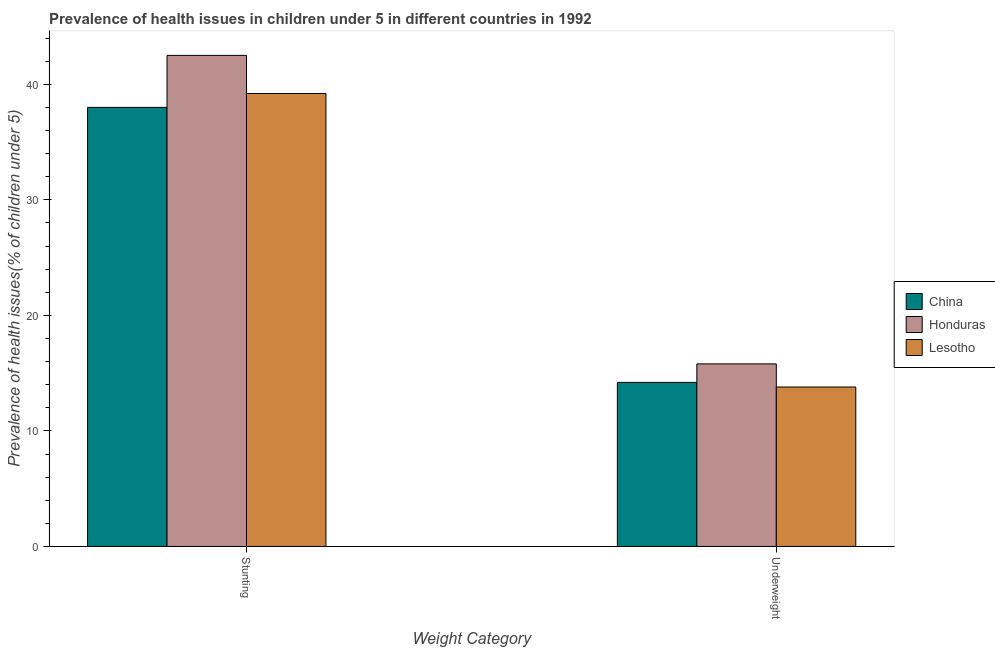Are the number of bars on each tick of the X-axis equal?
Offer a terse response. Yes. How many bars are there on the 2nd tick from the left?
Your response must be concise. 3. What is the label of the 1st group of bars from the left?
Make the answer very short. Stunting. What is the percentage of underweight children in Lesotho?
Make the answer very short. 13.8. Across all countries, what is the maximum percentage of stunted children?
Keep it short and to the point. 42.5. Across all countries, what is the minimum percentage of underweight children?
Provide a short and direct response. 13.8. In which country was the percentage of stunted children maximum?
Ensure brevity in your answer.  Honduras. In which country was the percentage of stunted children minimum?
Make the answer very short. China. What is the total percentage of underweight children in the graph?
Provide a short and direct response. 43.8. What is the difference between the percentage of stunted children in Lesotho and that in Honduras?
Your response must be concise. -3.3. What is the difference between the percentage of stunted children in China and the percentage of underweight children in Lesotho?
Provide a succinct answer. 24.2. What is the average percentage of stunted children per country?
Give a very brief answer. 39.9. What is the difference between the percentage of stunted children and percentage of underweight children in Honduras?
Provide a short and direct response. 26.7. What is the ratio of the percentage of stunted children in Honduras to that in China?
Offer a terse response. 1.12. Is the percentage of stunted children in Honduras less than that in China?
Give a very brief answer. No. In how many countries, is the percentage of underweight children greater than the average percentage of underweight children taken over all countries?
Give a very brief answer. 1. What does the 2nd bar from the left in Stunting represents?
Provide a short and direct response. Honduras. What does the 1st bar from the right in Underweight represents?
Ensure brevity in your answer.  Lesotho. How many countries are there in the graph?
Your answer should be very brief. 3. What is the difference between two consecutive major ticks on the Y-axis?
Your answer should be compact. 10. Does the graph contain any zero values?
Keep it short and to the point. No. Does the graph contain grids?
Provide a succinct answer. No. What is the title of the graph?
Keep it short and to the point. Prevalence of health issues in children under 5 in different countries in 1992. Does "Peru" appear as one of the legend labels in the graph?
Provide a succinct answer. No. What is the label or title of the X-axis?
Your response must be concise. Weight Category. What is the label or title of the Y-axis?
Your answer should be very brief. Prevalence of health issues(% of children under 5). What is the Prevalence of health issues(% of children under 5) of Honduras in Stunting?
Give a very brief answer. 42.5. What is the Prevalence of health issues(% of children under 5) in Lesotho in Stunting?
Offer a terse response. 39.2. What is the Prevalence of health issues(% of children under 5) in China in Underweight?
Keep it short and to the point. 14.2. What is the Prevalence of health issues(% of children under 5) in Honduras in Underweight?
Offer a terse response. 15.8. What is the Prevalence of health issues(% of children under 5) of Lesotho in Underweight?
Ensure brevity in your answer.  13.8. Across all Weight Category, what is the maximum Prevalence of health issues(% of children under 5) of Honduras?
Provide a short and direct response. 42.5. Across all Weight Category, what is the maximum Prevalence of health issues(% of children under 5) of Lesotho?
Offer a very short reply. 39.2. Across all Weight Category, what is the minimum Prevalence of health issues(% of children under 5) in China?
Provide a short and direct response. 14.2. Across all Weight Category, what is the minimum Prevalence of health issues(% of children under 5) of Honduras?
Give a very brief answer. 15.8. Across all Weight Category, what is the minimum Prevalence of health issues(% of children under 5) of Lesotho?
Offer a very short reply. 13.8. What is the total Prevalence of health issues(% of children under 5) in China in the graph?
Your answer should be compact. 52.2. What is the total Prevalence of health issues(% of children under 5) of Honduras in the graph?
Offer a very short reply. 58.3. What is the difference between the Prevalence of health issues(% of children under 5) of China in Stunting and that in Underweight?
Make the answer very short. 23.8. What is the difference between the Prevalence of health issues(% of children under 5) in Honduras in Stunting and that in Underweight?
Your response must be concise. 26.7. What is the difference between the Prevalence of health issues(% of children under 5) of Lesotho in Stunting and that in Underweight?
Offer a terse response. 25.4. What is the difference between the Prevalence of health issues(% of children under 5) of China in Stunting and the Prevalence of health issues(% of children under 5) of Honduras in Underweight?
Offer a terse response. 22.2. What is the difference between the Prevalence of health issues(% of children under 5) in China in Stunting and the Prevalence of health issues(% of children under 5) in Lesotho in Underweight?
Your answer should be compact. 24.2. What is the difference between the Prevalence of health issues(% of children under 5) of Honduras in Stunting and the Prevalence of health issues(% of children under 5) of Lesotho in Underweight?
Your answer should be very brief. 28.7. What is the average Prevalence of health issues(% of children under 5) in China per Weight Category?
Provide a succinct answer. 26.1. What is the average Prevalence of health issues(% of children under 5) of Honduras per Weight Category?
Keep it short and to the point. 29.15. What is the difference between the Prevalence of health issues(% of children under 5) of China and Prevalence of health issues(% of children under 5) of Honduras in Stunting?
Keep it short and to the point. -4.5. What is the difference between the Prevalence of health issues(% of children under 5) of Honduras and Prevalence of health issues(% of children under 5) of Lesotho in Underweight?
Offer a very short reply. 2. What is the ratio of the Prevalence of health issues(% of children under 5) of China in Stunting to that in Underweight?
Give a very brief answer. 2.68. What is the ratio of the Prevalence of health issues(% of children under 5) of Honduras in Stunting to that in Underweight?
Keep it short and to the point. 2.69. What is the ratio of the Prevalence of health issues(% of children under 5) of Lesotho in Stunting to that in Underweight?
Provide a short and direct response. 2.84. What is the difference between the highest and the second highest Prevalence of health issues(% of children under 5) in China?
Offer a terse response. 23.8. What is the difference between the highest and the second highest Prevalence of health issues(% of children under 5) in Honduras?
Provide a succinct answer. 26.7. What is the difference between the highest and the second highest Prevalence of health issues(% of children under 5) in Lesotho?
Provide a succinct answer. 25.4. What is the difference between the highest and the lowest Prevalence of health issues(% of children under 5) of China?
Make the answer very short. 23.8. What is the difference between the highest and the lowest Prevalence of health issues(% of children under 5) in Honduras?
Offer a very short reply. 26.7. What is the difference between the highest and the lowest Prevalence of health issues(% of children under 5) in Lesotho?
Provide a short and direct response. 25.4. 